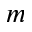Convert formula to latex. <formula><loc_0><loc_0><loc_500><loc_500>m</formula> 